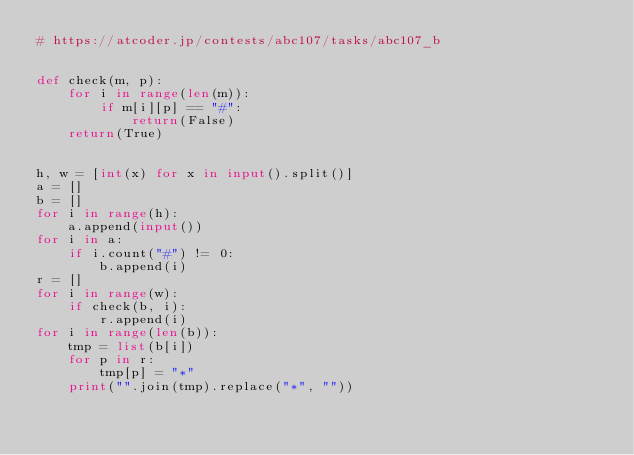<code> <loc_0><loc_0><loc_500><loc_500><_Python_># https://atcoder.jp/contests/abc107/tasks/abc107_b


def check(m, p):
    for i in range(len(m)):
        if m[i][p] == "#":
            return(False)
    return(True)


h, w = [int(x) for x in input().split()]
a = []
b = []
for i in range(h):
    a.append(input())
for i in a:
    if i.count("#") != 0:
        b.append(i)
r = []
for i in range(w):
    if check(b, i):
        r.append(i)
for i in range(len(b)):
    tmp = list(b[i])
    for p in r:
        tmp[p] = "*"
    print("".join(tmp).replace("*", ""))
</code> 